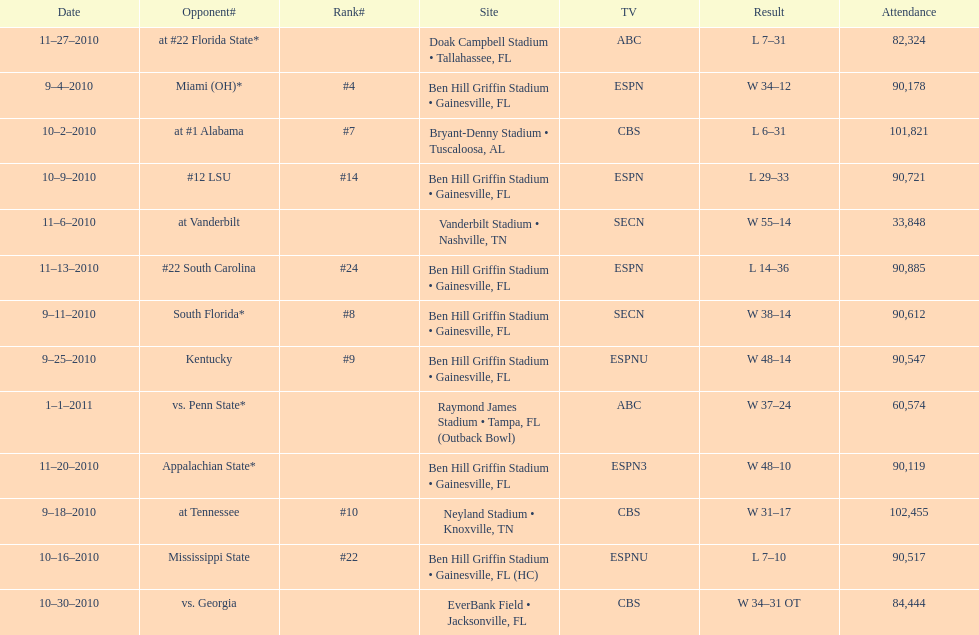How many matches occurred at ben hill griffin stadium throughout the 2010-2011 season? 7. 